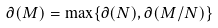Convert formula to latex. <formula><loc_0><loc_0><loc_500><loc_500>\partial ( M ) = \max \{ \partial ( N ) , \partial ( M / N ) \}</formula> 